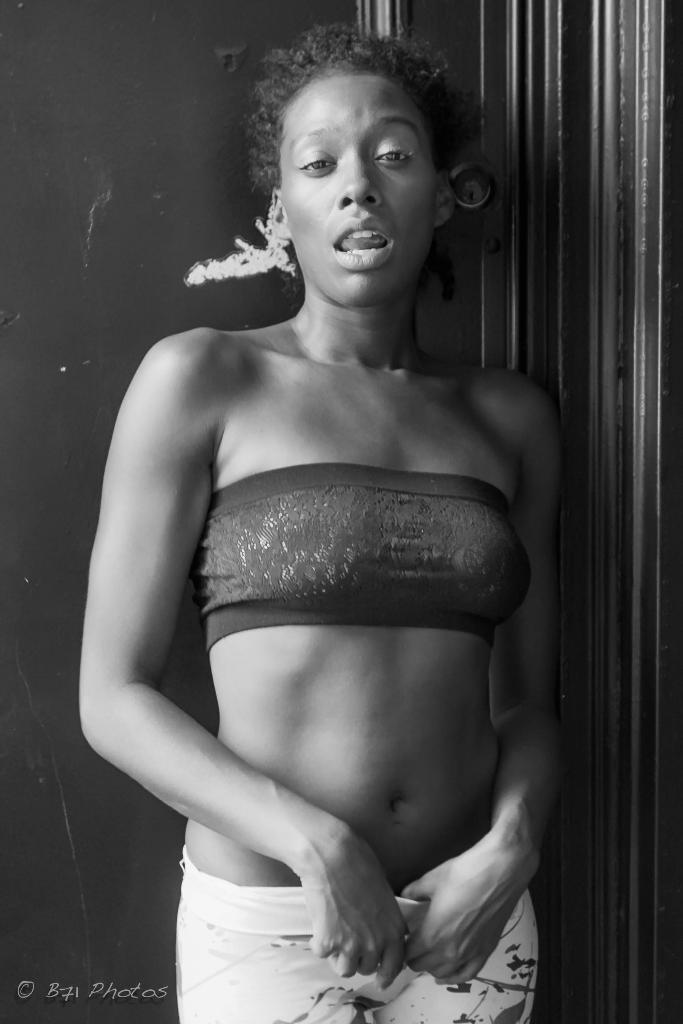What is the main subject of the image? There is a woman standing in the image. What is behind the woman in the image? There is a wall behind the woman. Is there any text or marking on the image? Yes, there is a watermark on the left side of the image. What color scheme is used in the image? The image is black and white. How many babies are crawling on the woman's ear in the image? There are no babies present in the image, and the woman's ear is not visible. 